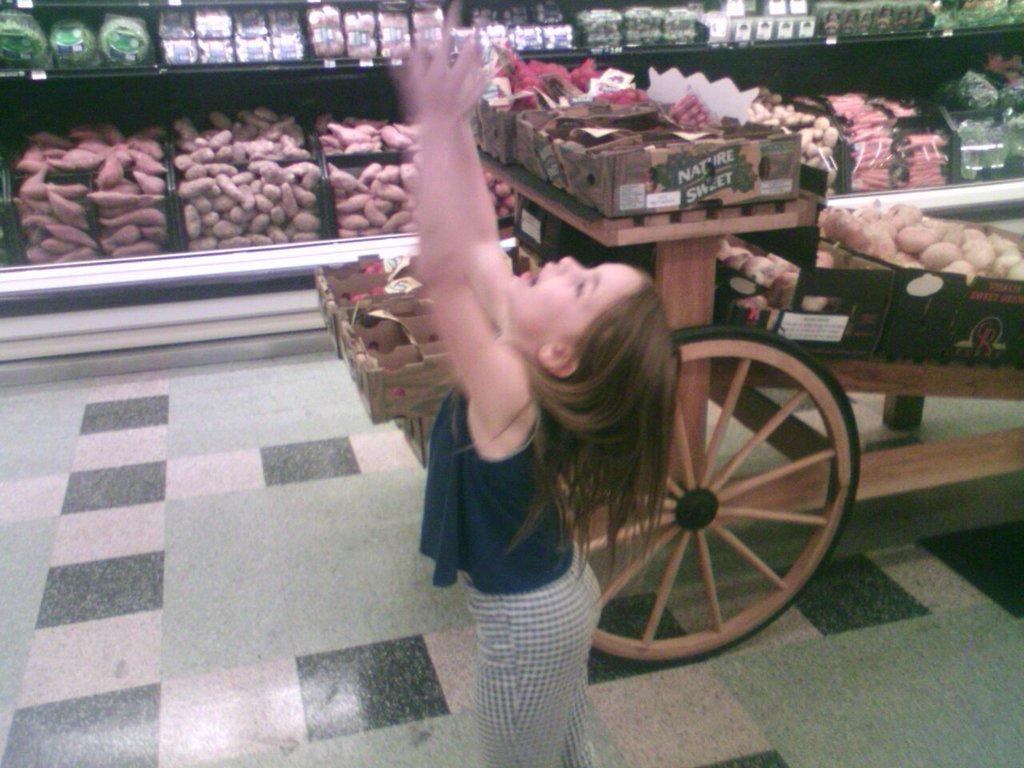How would you summarize this image in a sentence or two? There is a girl. Near to her there is a cart. On that there are some boxes and some other items. In the back there are racks. On the racks there are vegetables, boxes and many other items. 